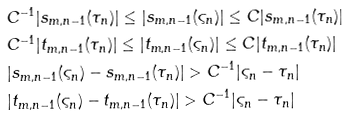Convert formula to latex. <formula><loc_0><loc_0><loc_500><loc_500>& C ^ { - 1 } | s _ { m , n - 1 } ( \tau _ { n } ) | \leq | s _ { m , n - 1 } ( \varsigma _ { n } ) | \leq C | s _ { m , n - 1 } ( \tau _ { n } ) | \\ & C ^ { - 1 } | t _ { m , n - 1 } ( \tau _ { n } ) | \leq | t _ { m , n - 1 } ( \varsigma _ { n } ) | \leq C | t _ { m , n - 1 } ( \tau _ { n } ) | \\ & | s _ { m , n - 1 } ( \varsigma _ { n } ) - s _ { m , n - 1 } ( \tau _ { n } ) | > C ^ { - 1 } | \varsigma _ { n } - \tau _ { n } | \\ & | t _ { m , n - 1 } ( \varsigma _ { n } ) - t _ { m , n - 1 } ( \tau _ { n } ) | > C ^ { - 1 } | \varsigma _ { n } - \tau _ { n } |</formula> 